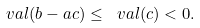Convert formula to latex. <formula><loc_0><loc_0><loc_500><loc_500>\ v a l ( b - a c ) \leq \ v a l ( c ) < 0 .</formula> 